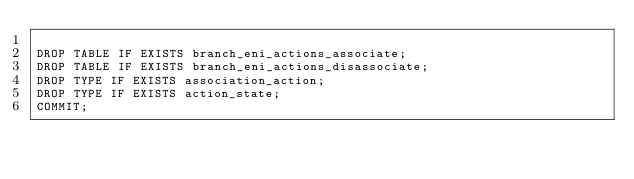<code> <loc_0><loc_0><loc_500><loc_500><_SQL_>
DROP TABLE IF EXISTS branch_eni_actions_associate;
DROP TABLE IF EXISTS branch_eni_actions_disassociate;
DROP TYPE IF EXISTS association_action;
DROP TYPE IF EXISTS action_state;
COMMIT;</code> 